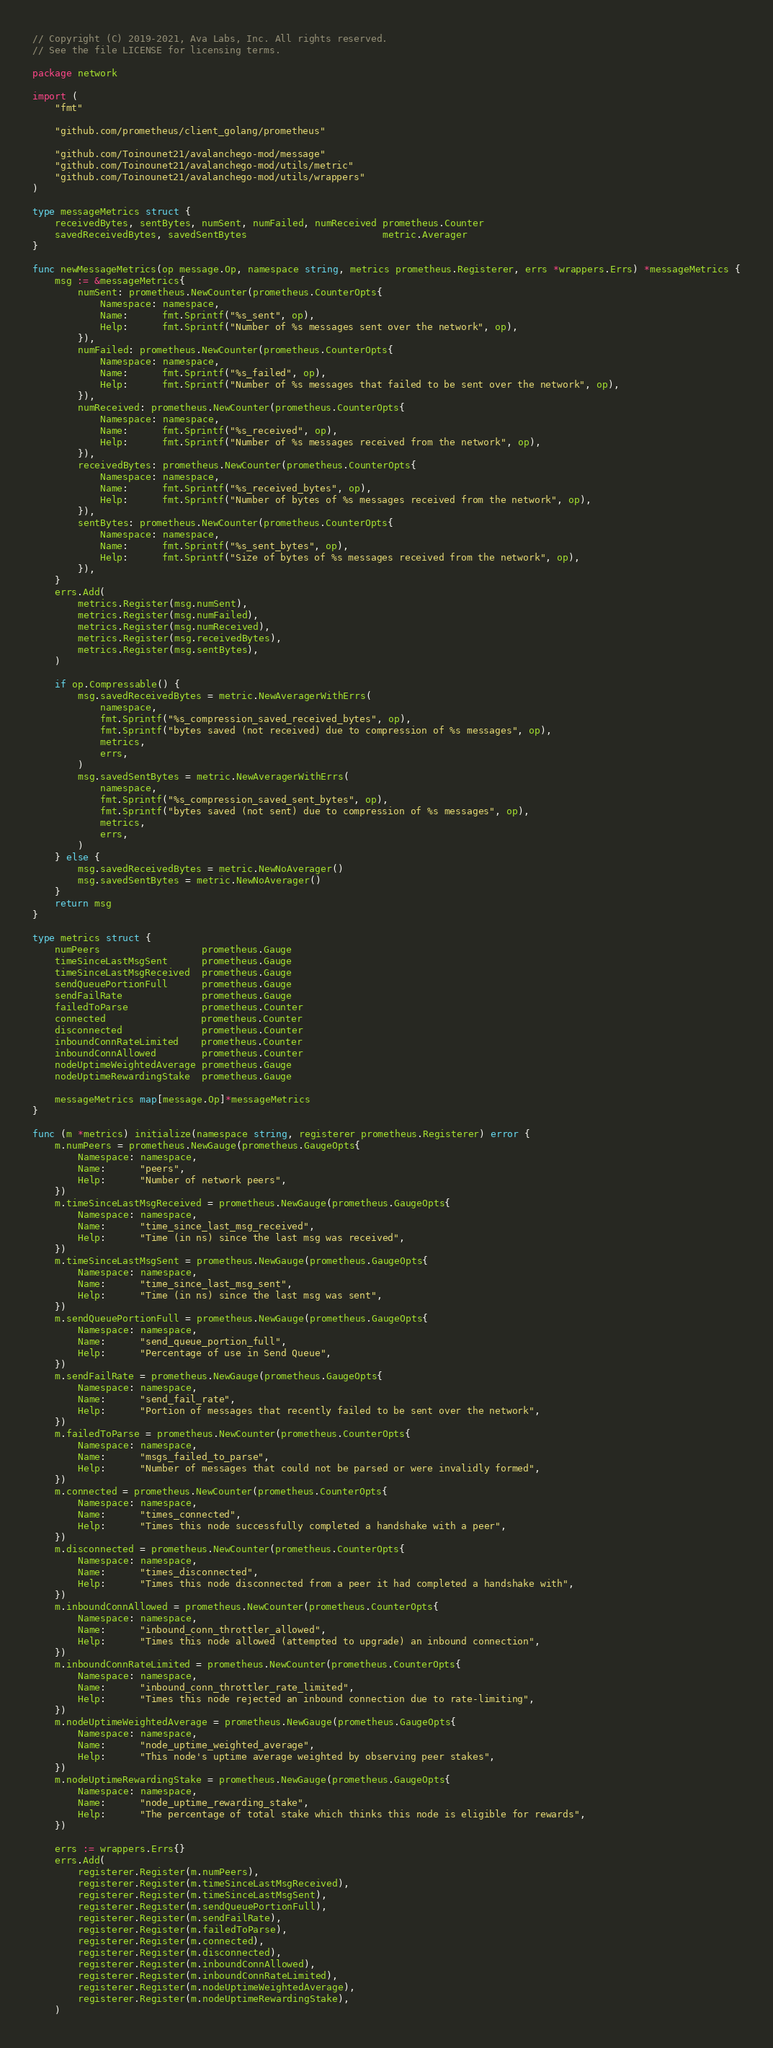Convert code to text. <code><loc_0><loc_0><loc_500><loc_500><_Go_>// Copyright (C) 2019-2021, Ava Labs, Inc. All rights reserved.
// See the file LICENSE for licensing terms.

package network

import (
	"fmt"

	"github.com/prometheus/client_golang/prometheus"

	"github.com/Toinounet21/avalanchego-mod/message"
	"github.com/Toinounet21/avalanchego-mod/utils/metric"
	"github.com/Toinounet21/avalanchego-mod/utils/wrappers"
)

type messageMetrics struct {
	receivedBytes, sentBytes, numSent, numFailed, numReceived prometheus.Counter
	savedReceivedBytes, savedSentBytes                        metric.Averager
}

func newMessageMetrics(op message.Op, namespace string, metrics prometheus.Registerer, errs *wrappers.Errs) *messageMetrics {
	msg := &messageMetrics{
		numSent: prometheus.NewCounter(prometheus.CounterOpts{
			Namespace: namespace,
			Name:      fmt.Sprintf("%s_sent", op),
			Help:      fmt.Sprintf("Number of %s messages sent over the network", op),
		}),
		numFailed: prometheus.NewCounter(prometheus.CounterOpts{
			Namespace: namespace,
			Name:      fmt.Sprintf("%s_failed", op),
			Help:      fmt.Sprintf("Number of %s messages that failed to be sent over the network", op),
		}),
		numReceived: prometheus.NewCounter(prometheus.CounterOpts{
			Namespace: namespace,
			Name:      fmt.Sprintf("%s_received", op),
			Help:      fmt.Sprintf("Number of %s messages received from the network", op),
		}),
		receivedBytes: prometheus.NewCounter(prometheus.CounterOpts{
			Namespace: namespace,
			Name:      fmt.Sprintf("%s_received_bytes", op),
			Help:      fmt.Sprintf("Number of bytes of %s messages received from the network", op),
		}),
		sentBytes: prometheus.NewCounter(prometheus.CounterOpts{
			Namespace: namespace,
			Name:      fmt.Sprintf("%s_sent_bytes", op),
			Help:      fmt.Sprintf("Size of bytes of %s messages received from the network", op),
		}),
	}
	errs.Add(
		metrics.Register(msg.numSent),
		metrics.Register(msg.numFailed),
		metrics.Register(msg.numReceived),
		metrics.Register(msg.receivedBytes),
		metrics.Register(msg.sentBytes),
	)

	if op.Compressable() {
		msg.savedReceivedBytes = metric.NewAveragerWithErrs(
			namespace,
			fmt.Sprintf("%s_compression_saved_received_bytes", op),
			fmt.Sprintf("bytes saved (not received) due to compression of %s messages", op),
			metrics,
			errs,
		)
		msg.savedSentBytes = metric.NewAveragerWithErrs(
			namespace,
			fmt.Sprintf("%s_compression_saved_sent_bytes", op),
			fmt.Sprintf("bytes saved (not sent) due to compression of %s messages", op),
			metrics,
			errs,
		)
	} else {
		msg.savedReceivedBytes = metric.NewNoAverager()
		msg.savedSentBytes = metric.NewNoAverager()
	}
	return msg
}

type metrics struct {
	numPeers                  prometheus.Gauge
	timeSinceLastMsgSent      prometheus.Gauge
	timeSinceLastMsgReceived  prometheus.Gauge
	sendQueuePortionFull      prometheus.Gauge
	sendFailRate              prometheus.Gauge
	failedToParse             prometheus.Counter
	connected                 prometheus.Counter
	disconnected              prometheus.Counter
	inboundConnRateLimited    prometheus.Counter
	inboundConnAllowed        prometheus.Counter
	nodeUptimeWeightedAverage prometheus.Gauge
	nodeUptimeRewardingStake  prometheus.Gauge

	messageMetrics map[message.Op]*messageMetrics
}

func (m *metrics) initialize(namespace string, registerer prometheus.Registerer) error {
	m.numPeers = prometheus.NewGauge(prometheus.GaugeOpts{
		Namespace: namespace,
		Name:      "peers",
		Help:      "Number of network peers",
	})
	m.timeSinceLastMsgReceived = prometheus.NewGauge(prometheus.GaugeOpts{
		Namespace: namespace,
		Name:      "time_since_last_msg_received",
		Help:      "Time (in ns) since the last msg was received",
	})
	m.timeSinceLastMsgSent = prometheus.NewGauge(prometheus.GaugeOpts{
		Namespace: namespace,
		Name:      "time_since_last_msg_sent",
		Help:      "Time (in ns) since the last msg was sent",
	})
	m.sendQueuePortionFull = prometheus.NewGauge(prometheus.GaugeOpts{
		Namespace: namespace,
		Name:      "send_queue_portion_full",
		Help:      "Percentage of use in Send Queue",
	})
	m.sendFailRate = prometheus.NewGauge(prometheus.GaugeOpts{
		Namespace: namespace,
		Name:      "send_fail_rate",
		Help:      "Portion of messages that recently failed to be sent over the network",
	})
	m.failedToParse = prometheus.NewCounter(prometheus.CounterOpts{
		Namespace: namespace,
		Name:      "msgs_failed_to_parse",
		Help:      "Number of messages that could not be parsed or were invalidly formed",
	})
	m.connected = prometheus.NewCounter(prometheus.CounterOpts{
		Namespace: namespace,
		Name:      "times_connected",
		Help:      "Times this node successfully completed a handshake with a peer",
	})
	m.disconnected = prometheus.NewCounter(prometheus.CounterOpts{
		Namespace: namespace,
		Name:      "times_disconnected",
		Help:      "Times this node disconnected from a peer it had completed a handshake with",
	})
	m.inboundConnAllowed = prometheus.NewCounter(prometheus.CounterOpts{
		Namespace: namespace,
		Name:      "inbound_conn_throttler_allowed",
		Help:      "Times this node allowed (attempted to upgrade) an inbound connection",
	})
	m.inboundConnRateLimited = prometheus.NewCounter(prometheus.CounterOpts{
		Namespace: namespace,
		Name:      "inbound_conn_throttler_rate_limited",
		Help:      "Times this node rejected an inbound connection due to rate-limiting",
	})
	m.nodeUptimeWeightedAverage = prometheus.NewGauge(prometheus.GaugeOpts{
		Namespace: namespace,
		Name:      "node_uptime_weighted_average",
		Help:      "This node's uptime average weighted by observing peer stakes",
	})
	m.nodeUptimeRewardingStake = prometheus.NewGauge(prometheus.GaugeOpts{
		Namespace: namespace,
		Name:      "node_uptime_rewarding_stake",
		Help:      "The percentage of total stake which thinks this node is eligible for rewards",
	})

	errs := wrappers.Errs{}
	errs.Add(
		registerer.Register(m.numPeers),
		registerer.Register(m.timeSinceLastMsgReceived),
		registerer.Register(m.timeSinceLastMsgSent),
		registerer.Register(m.sendQueuePortionFull),
		registerer.Register(m.sendFailRate),
		registerer.Register(m.failedToParse),
		registerer.Register(m.connected),
		registerer.Register(m.disconnected),
		registerer.Register(m.inboundConnAllowed),
		registerer.Register(m.inboundConnRateLimited),
		registerer.Register(m.nodeUptimeWeightedAverage),
		registerer.Register(m.nodeUptimeRewardingStake),
	)
</code> 